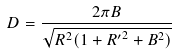<formula> <loc_0><loc_0><loc_500><loc_500>D = \frac { 2 \pi B } { \sqrt { R ^ { 2 } ( 1 + { R ^ { \prime } } ^ { 2 } + B ^ { 2 } ) } }</formula> 